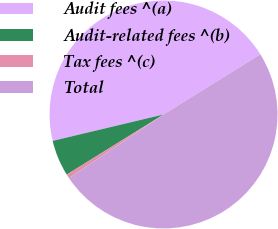Convert chart. <chart><loc_0><loc_0><loc_500><loc_500><pie_chart><fcel>Audit fees ^(a)<fcel>Audit-related fees ^(b)<fcel>Tax fees ^(c)<fcel>Total<nl><fcel>44.87%<fcel>5.13%<fcel>0.58%<fcel>49.42%<nl></chart> 